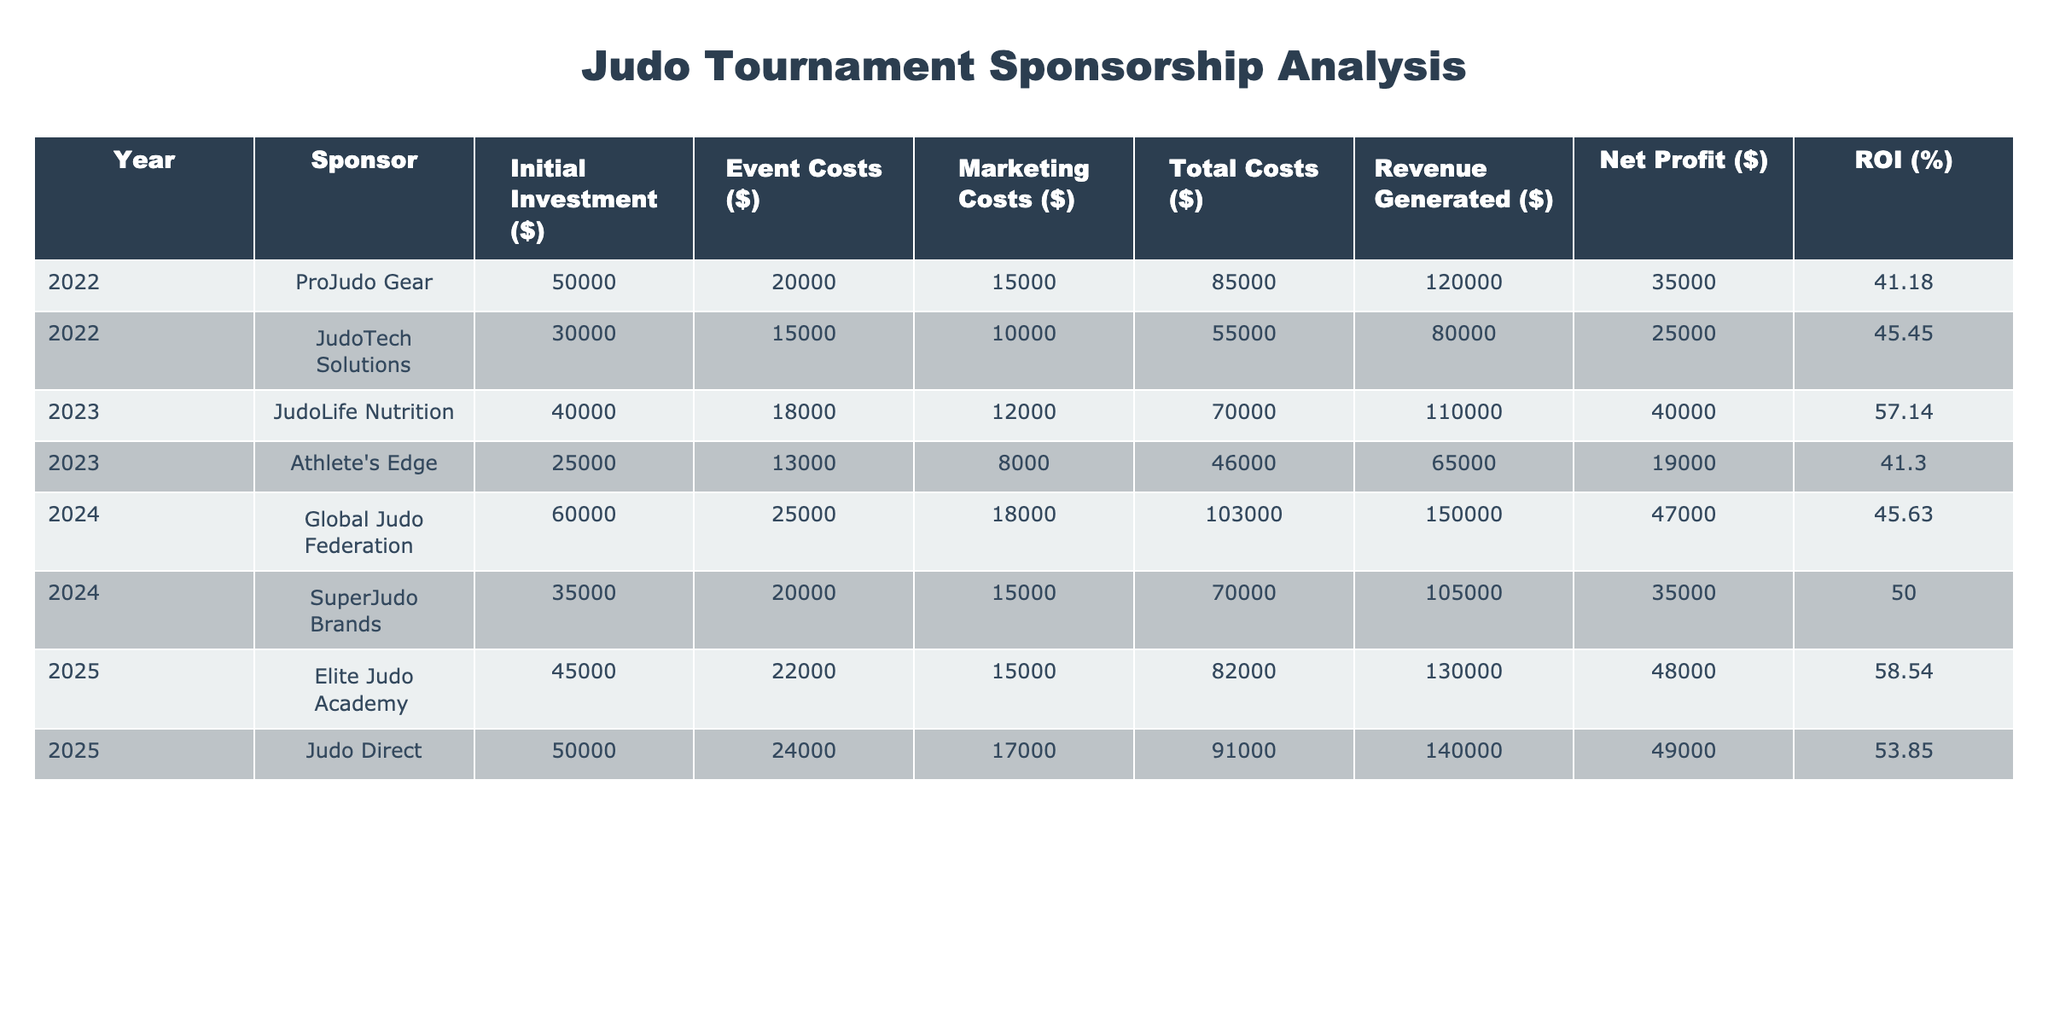What's the total initial investment made by all sponsors in 2022? From the table, the initial investments in 2022 are $50,000 from ProJudo Gear and $30,000 from JudoTech Solutions. Adding these amounts gives $50,000 + $30,000 = $80,000.
Answer: 80000 What is the net profit for JudoLife Nutrition in 2023? The table shows JudoLife Nutrition's net profit in 2023 is directly listed as $40,000.
Answer: 40000 Is the ROI for SuperJudo Brands higher than Judo Direct? The ROI for SuperJudo Brands is 50.00% and for Judo Direct is 53.85%. Since 53.85 is greater than 50.00, SuperJudo Brands does not have a higher ROI.
Answer: No What is the average revenue generated by sponsors from 2022 to 2025? The revenue figures for the years are $120,000 (ProJudo Gear), $80,000 (JudoTech Solutions), $110,000 (JudoLife Nutrition), $65,000 (Athlete's Edge), $150,000 (Global Judo Federation), $105,000 (SuperJudo Brands), $130,000 (Elite Judo Academy), and $140,000 (Judo Direct). Summing these gives $1,060,000. There are 8 sponsors, so the average revenue is $1,060,000 / 8 = $132,500.
Answer: 132500 Which year had the highest amount of total costs and what was the amount? The total costs for each year are $85,000 (2022, ProJudo Gear), $55,000 (2022, JudoTech Solutions), $70,000 (2023, JudoLife Nutrition), $46,000 (2023, Athlete's Edge), $103,000 (2024, Global Judo Federation), $70,000 (2024, SuperJudo Brands), $82,000 (2025, Elite Judo Academy), and $91,000 (2025, Judo Direct). The highest total cost is $103,000 in 2024.
Answer: 2024, 103000 What is the total net profit across all sponsors from 2022 to 2025? The net profits for each sponsor are $35,000 (ProJudo Gear), $25,000 (JudoTech Solutions), $40,000 (JudoLife Nutrition), $19,000 (Athlete's Edge), $47,000 (Global Judo Federation), $35,000 (SuperJudo Brands), $48,000 (Elite Judo Academy), and $49,000 (Judo Direct). Adding these amounts gives $35,000 + $25,000 + $40,000 + $19,000 + $47,000 + $35,000 + $48,000 + $49,000 = $298,000.
Answer: 298000 Which sponsor had the lowest amount of event costs in 2023? The table indicates that in 2023, the event costs are $18,000 (JudoLife Nutrition) and $13,000 (Athlete's Edge). The lowest event cost in 2023 is $13,000 from Athlete's Edge.
Answer: Athlete's Edge, 13000 What is the difference between the highest and lowest ROI among all sponsors? From the ROI values, the highest is 58.54% (Elite Judo Academy) and the lowest is 41.18% (ProJudo Gear). The difference is 58.54 - 41.18 = 17.36%.
Answer: 17.36 